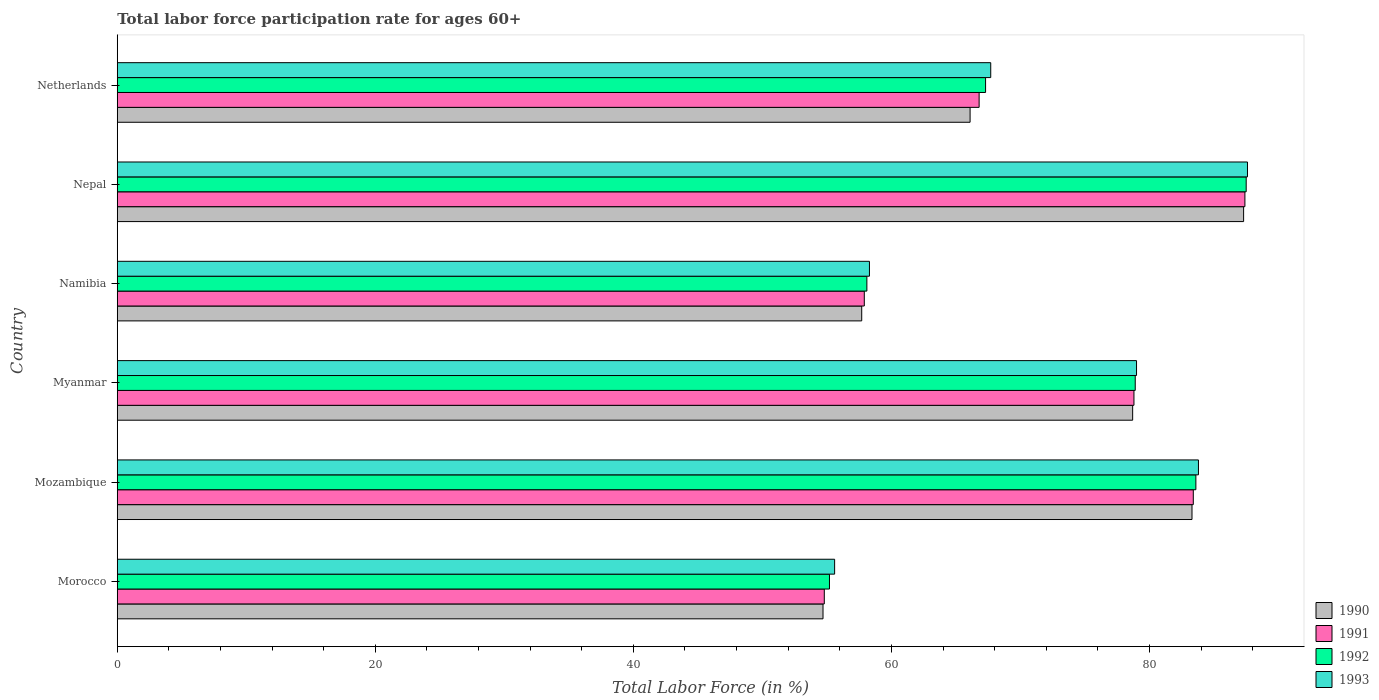How many different coloured bars are there?
Offer a terse response. 4. How many groups of bars are there?
Keep it short and to the point. 6. Are the number of bars per tick equal to the number of legend labels?
Offer a terse response. Yes. Are the number of bars on each tick of the Y-axis equal?
Provide a succinct answer. Yes. How many bars are there on the 6th tick from the top?
Ensure brevity in your answer.  4. How many bars are there on the 5th tick from the bottom?
Provide a succinct answer. 4. What is the label of the 5th group of bars from the top?
Your answer should be very brief. Mozambique. In how many cases, is the number of bars for a given country not equal to the number of legend labels?
Your response must be concise. 0. What is the labor force participation rate in 1991 in Netherlands?
Provide a succinct answer. 66.8. Across all countries, what is the maximum labor force participation rate in 1991?
Offer a terse response. 87.4. Across all countries, what is the minimum labor force participation rate in 1990?
Your answer should be very brief. 54.7. In which country was the labor force participation rate in 1990 maximum?
Offer a terse response. Nepal. In which country was the labor force participation rate in 1990 minimum?
Your response must be concise. Morocco. What is the total labor force participation rate in 1993 in the graph?
Offer a terse response. 432. What is the difference between the labor force participation rate in 1993 in Morocco and that in Netherlands?
Keep it short and to the point. -12.1. What is the difference between the labor force participation rate in 1992 in Mozambique and the labor force participation rate in 1990 in Morocco?
Offer a very short reply. 28.9. What is the average labor force participation rate in 1993 per country?
Offer a terse response. 72. What is the difference between the labor force participation rate in 1991 and labor force participation rate in 1992 in Myanmar?
Your answer should be compact. -0.1. In how many countries, is the labor force participation rate in 1991 greater than 44 %?
Give a very brief answer. 6. What is the ratio of the labor force participation rate in 1991 in Morocco to that in Namibia?
Provide a succinct answer. 0.95. Is the labor force participation rate in 1993 in Nepal less than that in Netherlands?
Ensure brevity in your answer.  No. Is the difference between the labor force participation rate in 1991 in Myanmar and Namibia greater than the difference between the labor force participation rate in 1992 in Myanmar and Namibia?
Ensure brevity in your answer.  Yes. What is the difference between the highest and the second highest labor force participation rate in 1992?
Keep it short and to the point. 3.9. What is the difference between the highest and the lowest labor force participation rate in 1992?
Keep it short and to the point. 32.3. In how many countries, is the labor force participation rate in 1990 greater than the average labor force participation rate in 1990 taken over all countries?
Your response must be concise. 3. What does the 3rd bar from the top in Mozambique represents?
Your answer should be compact. 1991. What is the difference between two consecutive major ticks on the X-axis?
Make the answer very short. 20. Does the graph contain grids?
Your answer should be very brief. No. How many legend labels are there?
Give a very brief answer. 4. What is the title of the graph?
Offer a terse response. Total labor force participation rate for ages 60+. What is the label or title of the Y-axis?
Give a very brief answer. Country. What is the Total Labor Force (in %) in 1990 in Morocco?
Offer a very short reply. 54.7. What is the Total Labor Force (in %) of 1991 in Morocco?
Offer a terse response. 54.8. What is the Total Labor Force (in %) in 1992 in Morocco?
Ensure brevity in your answer.  55.2. What is the Total Labor Force (in %) in 1993 in Morocco?
Make the answer very short. 55.6. What is the Total Labor Force (in %) in 1990 in Mozambique?
Keep it short and to the point. 83.3. What is the Total Labor Force (in %) in 1991 in Mozambique?
Your answer should be very brief. 83.4. What is the Total Labor Force (in %) in 1992 in Mozambique?
Your response must be concise. 83.6. What is the Total Labor Force (in %) of 1993 in Mozambique?
Your response must be concise. 83.8. What is the Total Labor Force (in %) in 1990 in Myanmar?
Your response must be concise. 78.7. What is the Total Labor Force (in %) of 1991 in Myanmar?
Your response must be concise. 78.8. What is the Total Labor Force (in %) in 1992 in Myanmar?
Provide a succinct answer. 78.9. What is the Total Labor Force (in %) of 1993 in Myanmar?
Your answer should be very brief. 79. What is the Total Labor Force (in %) of 1990 in Namibia?
Provide a succinct answer. 57.7. What is the Total Labor Force (in %) of 1991 in Namibia?
Provide a succinct answer. 57.9. What is the Total Labor Force (in %) of 1992 in Namibia?
Keep it short and to the point. 58.1. What is the Total Labor Force (in %) of 1993 in Namibia?
Provide a short and direct response. 58.3. What is the Total Labor Force (in %) in 1990 in Nepal?
Offer a terse response. 87.3. What is the Total Labor Force (in %) in 1991 in Nepal?
Keep it short and to the point. 87.4. What is the Total Labor Force (in %) in 1992 in Nepal?
Keep it short and to the point. 87.5. What is the Total Labor Force (in %) of 1993 in Nepal?
Give a very brief answer. 87.6. What is the Total Labor Force (in %) in 1990 in Netherlands?
Offer a terse response. 66.1. What is the Total Labor Force (in %) of 1991 in Netherlands?
Your answer should be very brief. 66.8. What is the Total Labor Force (in %) in 1992 in Netherlands?
Give a very brief answer. 67.3. What is the Total Labor Force (in %) in 1993 in Netherlands?
Provide a succinct answer. 67.7. Across all countries, what is the maximum Total Labor Force (in %) in 1990?
Keep it short and to the point. 87.3. Across all countries, what is the maximum Total Labor Force (in %) of 1991?
Give a very brief answer. 87.4. Across all countries, what is the maximum Total Labor Force (in %) in 1992?
Give a very brief answer. 87.5. Across all countries, what is the maximum Total Labor Force (in %) in 1993?
Keep it short and to the point. 87.6. Across all countries, what is the minimum Total Labor Force (in %) of 1990?
Provide a succinct answer. 54.7. Across all countries, what is the minimum Total Labor Force (in %) of 1991?
Make the answer very short. 54.8. Across all countries, what is the minimum Total Labor Force (in %) in 1992?
Ensure brevity in your answer.  55.2. Across all countries, what is the minimum Total Labor Force (in %) in 1993?
Offer a very short reply. 55.6. What is the total Total Labor Force (in %) of 1990 in the graph?
Give a very brief answer. 427.8. What is the total Total Labor Force (in %) in 1991 in the graph?
Provide a succinct answer. 429.1. What is the total Total Labor Force (in %) of 1992 in the graph?
Your answer should be compact. 430.6. What is the total Total Labor Force (in %) of 1993 in the graph?
Give a very brief answer. 432. What is the difference between the Total Labor Force (in %) of 1990 in Morocco and that in Mozambique?
Keep it short and to the point. -28.6. What is the difference between the Total Labor Force (in %) in 1991 in Morocco and that in Mozambique?
Keep it short and to the point. -28.6. What is the difference between the Total Labor Force (in %) of 1992 in Morocco and that in Mozambique?
Your answer should be compact. -28.4. What is the difference between the Total Labor Force (in %) of 1993 in Morocco and that in Mozambique?
Keep it short and to the point. -28.2. What is the difference between the Total Labor Force (in %) of 1990 in Morocco and that in Myanmar?
Keep it short and to the point. -24. What is the difference between the Total Labor Force (in %) of 1991 in Morocco and that in Myanmar?
Ensure brevity in your answer.  -24. What is the difference between the Total Labor Force (in %) in 1992 in Morocco and that in Myanmar?
Give a very brief answer. -23.7. What is the difference between the Total Labor Force (in %) in 1993 in Morocco and that in Myanmar?
Provide a succinct answer. -23.4. What is the difference between the Total Labor Force (in %) in 1991 in Morocco and that in Namibia?
Your response must be concise. -3.1. What is the difference between the Total Labor Force (in %) in 1992 in Morocco and that in Namibia?
Keep it short and to the point. -2.9. What is the difference between the Total Labor Force (in %) in 1993 in Morocco and that in Namibia?
Offer a terse response. -2.7. What is the difference between the Total Labor Force (in %) of 1990 in Morocco and that in Nepal?
Provide a succinct answer. -32.6. What is the difference between the Total Labor Force (in %) in 1991 in Morocco and that in Nepal?
Keep it short and to the point. -32.6. What is the difference between the Total Labor Force (in %) of 1992 in Morocco and that in Nepal?
Provide a succinct answer. -32.3. What is the difference between the Total Labor Force (in %) of 1993 in Morocco and that in Nepal?
Offer a very short reply. -32. What is the difference between the Total Labor Force (in %) in 1991 in Morocco and that in Netherlands?
Your answer should be compact. -12. What is the difference between the Total Labor Force (in %) of 1993 in Morocco and that in Netherlands?
Keep it short and to the point. -12.1. What is the difference between the Total Labor Force (in %) of 1990 in Mozambique and that in Myanmar?
Ensure brevity in your answer.  4.6. What is the difference between the Total Labor Force (in %) in 1991 in Mozambique and that in Myanmar?
Your response must be concise. 4.6. What is the difference between the Total Labor Force (in %) of 1993 in Mozambique and that in Myanmar?
Offer a terse response. 4.8. What is the difference between the Total Labor Force (in %) in 1990 in Mozambique and that in Namibia?
Give a very brief answer. 25.6. What is the difference between the Total Labor Force (in %) of 1991 in Mozambique and that in Namibia?
Keep it short and to the point. 25.5. What is the difference between the Total Labor Force (in %) in 1992 in Mozambique and that in Namibia?
Provide a short and direct response. 25.5. What is the difference between the Total Labor Force (in %) of 1993 in Mozambique and that in Namibia?
Make the answer very short. 25.5. What is the difference between the Total Labor Force (in %) of 1992 in Mozambique and that in Nepal?
Provide a short and direct response. -3.9. What is the difference between the Total Labor Force (in %) of 1993 in Mozambique and that in Nepal?
Your response must be concise. -3.8. What is the difference between the Total Labor Force (in %) in 1992 in Mozambique and that in Netherlands?
Provide a short and direct response. 16.3. What is the difference between the Total Labor Force (in %) of 1991 in Myanmar and that in Namibia?
Give a very brief answer. 20.9. What is the difference between the Total Labor Force (in %) of 1992 in Myanmar and that in Namibia?
Offer a terse response. 20.8. What is the difference between the Total Labor Force (in %) of 1993 in Myanmar and that in Namibia?
Give a very brief answer. 20.7. What is the difference between the Total Labor Force (in %) of 1991 in Myanmar and that in Nepal?
Provide a succinct answer. -8.6. What is the difference between the Total Labor Force (in %) in 1992 in Myanmar and that in Nepal?
Provide a short and direct response. -8.6. What is the difference between the Total Labor Force (in %) of 1992 in Myanmar and that in Netherlands?
Make the answer very short. 11.6. What is the difference between the Total Labor Force (in %) of 1993 in Myanmar and that in Netherlands?
Give a very brief answer. 11.3. What is the difference between the Total Labor Force (in %) in 1990 in Namibia and that in Nepal?
Provide a succinct answer. -29.6. What is the difference between the Total Labor Force (in %) of 1991 in Namibia and that in Nepal?
Your answer should be very brief. -29.5. What is the difference between the Total Labor Force (in %) of 1992 in Namibia and that in Nepal?
Make the answer very short. -29.4. What is the difference between the Total Labor Force (in %) in 1993 in Namibia and that in Nepal?
Offer a terse response. -29.3. What is the difference between the Total Labor Force (in %) in 1991 in Namibia and that in Netherlands?
Give a very brief answer. -8.9. What is the difference between the Total Labor Force (in %) of 1992 in Namibia and that in Netherlands?
Offer a terse response. -9.2. What is the difference between the Total Labor Force (in %) in 1990 in Nepal and that in Netherlands?
Keep it short and to the point. 21.2. What is the difference between the Total Labor Force (in %) of 1991 in Nepal and that in Netherlands?
Provide a short and direct response. 20.6. What is the difference between the Total Labor Force (in %) in 1992 in Nepal and that in Netherlands?
Your answer should be very brief. 20.2. What is the difference between the Total Labor Force (in %) of 1993 in Nepal and that in Netherlands?
Ensure brevity in your answer.  19.9. What is the difference between the Total Labor Force (in %) of 1990 in Morocco and the Total Labor Force (in %) of 1991 in Mozambique?
Make the answer very short. -28.7. What is the difference between the Total Labor Force (in %) of 1990 in Morocco and the Total Labor Force (in %) of 1992 in Mozambique?
Offer a very short reply. -28.9. What is the difference between the Total Labor Force (in %) in 1990 in Morocco and the Total Labor Force (in %) in 1993 in Mozambique?
Offer a terse response. -29.1. What is the difference between the Total Labor Force (in %) in 1991 in Morocco and the Total Labor Force (in %) in 1992 in Mozambique?
Make the answer very short. -28.8. What is the difference between the Total Labor Force (in %) in 1992 in Morocco and the Total Labor Force (in %) in 1993 in Mozambique?
Your answer should be very brief. -28.6. What is the difference between the Total Labor Force (in %) of 1990 in Morocco and the Total Labor Force (in %) of 1991 in Myanmar?
Make the answer very short. -24.1. What is the difference between the Total Labor Force (in %) of 1990 in Morocco and the Total Labor Force (in %) of 1992 in Myanmar?
Keep it short and to the point. -24.2. What is the difference between the Total Labor Force (in %) in 1990 in Morocco and the Total Labor Force (in %) in 1993 in Myanmar?
Your answer should be compact. -24.3. What is the difference between the Total Labor Force (in %) of 1991 in Morocco and the Total Labor Force (in %) of 1992 in Myanmar?
Keep it short and to the point. -24.1. What is the difference between the Total Labor Force (in %) in 1991 in Morocco and the Total Labor Force (in %) in 1993 in Myanmar?
Make the answer very short. -24.2. What is the difference between the Total Labor Force (in %) of 1992 in Morocco and the Total Labor Force (in %) of 1993 in Myanmar?
Offer a very short reply. -23.8. What is the difference between the Total Labor Force (in %) in 1990 in Morocco and the Total Labor Force (in %) in 1991 in Namibia?
Keep it short and to the point. -3.2. What is the difference between the Total Labor Force (in %) of 1990 in Morocco and the Total Labor Force (in %) of 1993 in Namibia?
Ensure brevity in your answer.  -3.6. What is the difference between the Total Labor Force (in %) of 1991 in Morocco and the Total Labor Force (in %) of 1993 in Namibia?
Provide a succinct answer. -3.5. What is the difference between the Total Labor Force (in %) in 1990 in Morocco and the Total Labor Force (in %) in 1991 in Nepal?
Offer a terse response. -32.7. What is the difference between the Total Labor Force (in %) of 1990 in Morocco and the Total Labor Force (in %) of 1992 in Nepal?
Your answer should be very brief. -32.8. What is the difference between the Total Labor Force (in %) of 1990 in Morocco and the Total Labor Force (in %) of 1993 in Nepal?
Your answer should be very brief. -32.9. What is the difference between the Total Labor Force (in %) of 1991 in Morocco and the Total Labor Force (in %) of 1992 in Nepal?
Keep it short and to the point. -32.7. What is the difference between the Total Labor Force (in %) of 1991 in Morocco and the Total Labor Force (in %) of 1993 in Nepal?
Your answer should be very brief. -32.8. What is the difference between the Total Labor Force (in %) in 1992 in Morocco and the Total Labor Force (in %) in 1993 in Nepal?
Give a very brief answer. -32.4. What is the difference between the Total Labor Force (in %) of 1990 in Morocco and the Total Labor Force (in %) of 1992 in Netherlands?
Your response must be concise. -12.6. What is the difference between the Total Labor Force (in %) of 1991 in Morocco and the Total Labor Force (in %) of 1992 in Netherlands?
Provide a succinct answer. -12.5. What is the difference between the Total Labor Force (in %) of 1991 in Morocco and the Total Labor Force (in %) of 1993 in Netherlands?
Provide a succinct answer. -12.9. What is the difference between the Total Labor Force (in %) in 1991 in Mozambique and the Total Labor Force (in %) in 1992 in Myanmar?
Keep it short and to the point. 4.5. What is the difference between the Total Labor Force (in %) of 1991 in Mozambique and the Total Labor Force (in %) of 1993 in Myanmar?
Your answer should be compact. 4.4. What is the difference between the Total Labor Force (in %) in 1992 in Mozambique and the Total Labor Force (in %) in 1993 in Myanmar?
Make the answer very short. 4.6. What is the difference between the Total Labor Force (in %) of 1990 in Mozambique and the Total Labor Force (in %) of 1991 in Namibia?
Offer a terse response. 25.4. What is the difference between the Total Labor Force (in %) in 1990 in Mozambique and the Total Labor Force (in %) in 1992 in Namibia?
Offer a very short reply. 25.2. What is the difference between the Total Labor Force (in %) in 1991 in Mozambique and the Total Labor Force (in %) in 1992 in Namibia?
Give a very brief answer. 25.3. What is the difference between the Total Labor Force (in %) in 1991 in Mozambique and the Total Labor Force (in %) in 1993 in Namibia?
Your answer should be very brief. 25.1. What is the difference between the Total Labor Force (in %) in 1992 in Mozambique and the Total Labor Force (in %) in 1993 in Namibia?
Offer a very short reply. 25.3. What is the difference between the Total Labor Force (in %) of 1990 in Mozambique and the Total Labor Force (in %) of 1991 in Nepal?
Your answer should be compact. -4.1. What is the difference between the Total Labor Force (in %) of 1990 in Mozambique and the Total Labor Force (in %) of 1993 in Nepal?
Make the answer very short. -4.3. What is the difference between the Total Labor Force (in %) of 1991 in Mozambique and the Total Labor Force (in %) of 1992 in Nepal?
Keep it short and to the point. -4.1. What is the difference between the Total Labor Force (in %) in 1991 in Mozambique and the Total Labor Force (in %) in 1993 in Nepal?
Your response must be concise. -4.2. What is the difference between the Total Labor Force (in %) in 1992 in Mozambique and the Total Labor Force (in %) in 1993 in Nepal?
Your answer should be very brief. -4. What is the difference between the Total Labor Force (in %) of 1990 in Mozambique and the Total Labor Force (in %) of 1991 in Netherlands?
Your answer should be compact. 16.5. What is the difference between the Total Labor Force (in %) in 1990 in Mozambique and the Total Labor Force (in %) in 1993 in Netherlands?
Offer a very short reply. 15.6. What is the difference between the Total Labor Force (in %) in 1992 in Mozambique and the Total Labor Force (in %) in 1993 in Netherlands?
Provide a short and direct response. 15.9. What is the difference between the Total Labor Force (in %) of 1990 in Myanmar and the Total Labor Force (in %) of 1991 in Namibia?
Provide a short and direct response. 20.8. What is the difference between the Total Labor Force (in %) of 1990 in Myanmar and the Total Labor Force (in %) of 1992 in Namibia?
Your answer should be very brief. 20.6. What is the difference between the Total Labor Force (in %) in 1990 in Myanmar and the Total Labor Force (in %) in 1993 in Namibia?
Provide a succinct answer. 20.4. What is the difference between the Total Labor Force (in %) in 1991 in Myanmar and the Total Labor Force (in %) in 1992 in Namibia?
Ensure brevity in your answer.  20.7. What is the difference between the Total Labor Force (in %) of 1991 in Myanmar and the Total Labor Force (in %) of 1993 in Namibia?
Offer a very short reply. 20.5. What is the difference between the Total Labor Force (in %) in 1992 in Myanmar and the Total Labor Force (in %) in 1993 in Namibia?
Give a very brief answer. 20.6. What is the difference between the Total Labor Force (in %) of 1990 in Myanmar and the Total Labor Force (in %) of 1991 in Nepal?
Provide a short and direct response. -8.7. What is the difference between the Total Labor Force (in %) of 1990 in Myanmar and the Total Labor Force (in %) of 1993 in Nepal?
Your response must be concise. -8.9. What is the difference between the Total Labor Force (in %) in 1992 in Myanmar and the Total Labor Force (in %) in 1993 in Nepal?
Your answer should be compact. -8.7. What is the difference between the Total Labor Force (in %) in 1990 in Myanmar and the Total Labor Force (in %) in 1991 in Netherlands?
Your response must be concise. 11.9. What is the difference between the Total Labor Force (in %) in 1990 in Myanmar and the Total Labor Force (in %) in 1992 in Netherlands?
Your answer should be compact. 11.4. What is the difference between the Total Labor Force (in %) in 1991 in Myanmar and the Total Labor Force (in %) in 1992 in Netherlands?
Provide a succinct answer. 11.5. What is the difference between the Total Labor Force (in %) in 1991 in Myanmar and the Total Labor Force (in %) in 1993 in Netherlands?
Your answer should be compact. 11.1. What is the difference between the Total Labor Force (in %) of 1990 in Namibia and the Total Labor Force (in %) of 1991 in Nepal?
Your response must be concise. -29.7. What is the difference between the Total Labor Force (in %) in 1990 in Namibia and the Total Labor Force (in %) in 1992 in Nepal?
Your answer should be very brief. -29.8. What is the difference between the Total Labor Force (in %) in 1990 in Namibia and the Total Labor Force (in %) in 1993 in Nepal?
Give a very brief answer. -29.9. What is the difference between the Total Labor Force (in %) in 1991 in Namibia and the Total Labor Force (in %) in 1992 in Nepal?
Give a very brief answer. -29.6. What is the difference between the Total Labor Force (in %) in 1991 in Namibia and the Total Labor Force (in %) in 1993 in Nepal?
Your answer should be compact. -29.7. What is the difference between the Total Labor Force (in %) of 1992 in Namibia and the Total Labor Force (in %) of 1993 in Nepal?
Ensure brevity in your answer.  -29.5. What is the difference between the Total Labor Force (in %) of 1990 in Namibia and the Total Labor Force (in %) of 1991 in Netherlands?
Your response must be concise. -9.1. What is the difference between the Total Labor Force (in %) of 1990 in Namibia and the Total Labor Force (in %) of 1992 in Netherlands?
Your answer should be compact. -9.6. What is the difference between the Total Labor Force (in %) of 1990 in Namibia and the Total Labor Force (in %) of 1993 in Netherlands?
Offer a very short reply. -10. What is the difference between the Total Labor Force (in %) of 1990 in Nepal and the Total Labor Force (in %) of 1991 in Netherlands?
Offer a very short reply. 20.5. What is the difference between the Total Labor Force (in %) of 1990 in Nepal and the Total Labor Force (in %) of 1993 in Netherlands?
Provide a short and direct response. 19.6. What is the difference between the Total Labor Force (in %) in 1991 in Nepal and the Total Labor Force (in %) in 1992 in Netherlands?
Offer a very short reply. 20.1. What is the difference between the Total Labor Force (in %) in 1991 in Nepal and the Total Labor Force (in %) in 1993 in Netherlands?
Provide a short and direct response. 19.7. What is the difference between the Total Labor Force (in %) in 1992 in Nepal and the Total Labor Force (in %) in 1993 in Netherlands?
Offer a very short reply. 19.8. What is the average Total Labor Force (in %) of 1990 per country?
Your response must be concise. 71.3. What is the average Total Labor Force (in %) of 1991 per country?
Offer a very short reply. 71.52. What is the average Total Labor Force (in %) of 1992 per country?
Offer a very short reply. 71.77. What is the average Total Labor Force (in %) in 1993 per country?
Make the answer very short. 72. What is the difference between the Total Labor Force (in %) of 1991 and Total Labor Force (in %) of 1992 in Morocco?
Offer a very short reply. -0.4. What is the difference between the Total Labor Force (in %) of 1991 and Total Labor Force (in %) of 1993 in Morocco?
Make the answer very short. -0.8. What is the difference between the Total Labor Force (in %) of 1990 and Total Labor Force (in %) of 1991 in Mozambique?
Ensure brevity in your answer.  -0.1. What is the difference between the Total Labor Force (in %) in 1990 and Total Labor Force (in %) in 1993 in Mozambique?
Your answer should be compact. -0.5. What is the difference between the Total Labor Force (in %) in 1991 and Total Labor Force (in %) in 1992 in Mozambique?
Offer a very short reply. -0.2. What is the difference between the Total Labor Force (in %) of 1991 and Total Labor Force (in %) of 1993 in Mozambique?
Provide a succinct answer. -0.4. What is the difference between the Total Labor Force (in %) of 1992 and Total Labor Force (in %) of 1993 in Mozambique?
Keep it short and to the point. -0.2. What is the difference between the Total Labor Force (in %) in 1990 and Total Labor Force (in %) in 1992 in Myanmar?
Your response must be concise. -0.2. What is the difference between the Total Labor Force (in %) of 1991 and Total Labor Force (in %) of 1992 in Myanmar?
Provide a short and direct response. -0.1. What is the difference between the Total Labor Force (in %) in 1991 and Total Labor Force (in %) in 1993 in Myanmar?
Provide a short and direct response. -0.2. What is the difference between the Total Labor Force (in %) in 1990 and Total Labor Force (in %) in 1992 in Namibia?
Your answer should be compact. -0.4. What is the difference between the Total Labor Force (in %) of 1990 and Total Labor Force (in %) of 1991 in Nepal?
Give a very brief answer. -0.1. What is the difference between the Total Labor Force (in %) in 1990 and Total Labor Force (in %) in 1992 in Netherlands?
Ensure brevity in your answer.  -1.2. What is the difference between the Total Labor Force (in %) in 1990 and Total Labor Force (in %) in 1993 in Netherlands?
Make the answer very short. -1.6. What is the ratio of the Total Labor Force (in %) of 1990 in Morocco to that in Mozambique?
Provide a succinct answer. 0.66. What is the ratio of the Total Labor Force (in %) in 1991 in Morocco to that in Mozambique?
Your answer should be very brief. 0.66. What is the ratio of the Total Labor Force (in %) of 1992 in Morocco to that in Mozambique?
Offer a terse response. 0.66. What is the ratio of the Total Labor Force (in %) in 1993 in Morocco to that in Mozambique?
Keep it short and to the point. 0.66. What is the ratio of the Total Labor Force (in %) in 1990 in Morocco to that in Myanmar?
Your response must be concise. 0.69. What is the ratio of the Total Labor Force (in %) in 1991 in Morocco to that in Myanmar?
Your answer should be very brief. 0.7. What is the ratio of the Total Labor Force (in %) in 1992 in Morocco to that in Myanmar?
Your response must be concise. 0.7. What is the ratio of the Total Labor Force (in %) in 1993 in Morocco to that in Myanmar?
Provide a succinct answer. 0.7. What is the ratio of the Total Labor Force (in %) of 1990 in Morocco to that in Namibia?
Your response must be concise. 0.95. What is the ratio of the Total Labor Force (in %) of 1991 in Morocco to that in Namibia?
Provide a short and direct response. 0.95. What is the ratio of the Total Labor Force (in %) of 1992 in Morocco to that in Namibia?
Keep it short and to the point. 0.95. What is the ratio of the Total Labor Force (in %) in 1993 in Morocco to that in Namibia?
Provide a short and direct response. 0.95. What is the ratio of the Total Labor Force (in %) of 1990 in Morocco to that in Nepal?
Provide a short and direct response. 0.63. What is the ratio of the Total Labor Force (in %) in 1991 in Morocco to that in Nepal?
Offer a very short reply. 0.63. What is the ratio of the Total Labor Force (in %) in 1992 in Morocco to that in Nepal?
Offer a terse response. 0.63. What is the ratio of the Total Labor Force (in %) of 1993 in Morocco to that in Nepal?
Give a very brief answer. 0.63. What is the ratio of the Total Labor Force (in %) of 1990 in Morocco to that in Netherlands?
Your response must be concise. 0.83. What is the ratio of the Total Labor Force (in %) in 1991 in Morocco to that in Netherlands?
Give a very brief answer. 0.82. What is the ratio of the Total Labor Force (in %) in 1992 in Morocco to that in Netherlands?
Your response must be concise. 0.82. What is the ratio of the Total Labor Force (in %) of 1993 in Morocco to that in Netherlands?
Your answer should be compact. 0.82. What is the ratio of the Total Labor Force (in %) of 1990 in Mozambique to that in Myanmar?
Provide a short and direct response. 1.06. What is the ratio of the Total Labor Force (in %) in 1991 in Mozambique to that in Myanmar?
Make the answer very short. 1.06. What is the ratio of the Total Labor Force (in %) of 1992 in Mozambique to that in Myanmar?
Give a very brief answer. 1.06. What is the ratio of the Total Labor Force (in %) of 1993 in Mozambique to that in Myanmar?
Your answer should be very brief. 1.06. What is the ratio of the Total Labor Force (in %) of 1990 in Mozambique to that in Namibia?
Provide a succinct answer. 1.44. What is the ratio of the Total Labor Force (in %) in 1991 in Mozambique to that in Namibia?
Provide a short and direct response. 1.44. What is the ratio of the Total Labor Force (in %) in 1992 in Mozambique to that in Namibia?
Offer a terse response. 1.44. What is the ratio of the Total Labor Force (in %) of 1993 in Mozambique to that in Namibia?
Give a very brief answer. 1.44. What is the ratio of the Total Labor Force (in %) of 1990 in Mozambique to that in Nepal?
Provide a short and direct response. 0.95. What is the ratio of the Total Labor Force (in %) of 1991 in Mozambique to that in Nepal?
Make the answer very short. 0.95. What is the ratio of the Total Labor Force (in %) in 1992 in Mozambique to that in Nepal?
Keep it short and to the point. 0.96. What is the ratio of the Total Labor Force (in %) in 1993 in Mozambique to that in Nepal?
Your answer should be compact. 0.96. What is the ratio of the Total Labor Force (in %) of 1990 in Mozambique to that in Netherlands?
Give a very brief answer. 1.26. What is the ratio of the Total Labor Force (in %) of 1991 in Mozambique to that in Netherlands?
Give a very brief answer. 1.25. What is the ratio of the Total Labor Force (in %) in 1992 in Mozambique to that in Netherlands?
Your response must be concise. 1.24. What is the ratio of the Total Labor Force (in %) of 1993 in Mozambique to that in Netherlands?
Make the answer very short. 1.24. What is the ratio of the Total Labor Force (in %) of 1990 in Myanmar to that in Namibia?
Give a very brief answer. 1.36. What is the ratio of the Total Labor Force (in %) in 1991 in Myanmar to that in Namibia?
Your response must be concise. 1.36. What is the ratio of the Total Labor Force (in %) in 1992 in Myanmar to that in Namibia?
Provide a short and direct response. 1.36. What is the ratio of the Total Labor Force (in %) of 1993 in Myanmar to that in Namibia?
Offer a very short reply. 1.36. What is the ratio of the Total Labor Force (in %) in 1990 in Myanmar to that in Nepal?
Ensure brevity in your answer.  0.9. What is the ratio of the Total Labor Force (in %) in 1991 in Myanmar to that in Nepal?
Provide a short and direct response. 0.9. What is the ratio of the Total Labor Force (in %) of 1992 in Myanmar to that in Nepal?
Your answer should be compact. 0.9. What is the ratio of the Total Labor Force (in %) of 1993 in Myanmar to that in Nepal?
Offer a very short reply. 0.9. What is the ratio of the Total Labor Force (in %) in 1990 in Myanmar to that in Netherlands?
Give a very brief answer. 1.19. What is the ratio of the Total Labor Force (in %) in 1991 in Myanmar to that in Netherlands?
Give a very brief answer. 1.18. What is the ratio of the Total Labor Force (in %) of 1992 in Myanmar to that in Netherlands?
Your answer should be very brief. 1.17. What is the ratio of the Total Labor Force (in %) in 1993 in Myanmar to that in Netherlands?
Provide a succinct answer. 1.17. What is the ratio of the Total Labor Force (in %) in 1990 in Namibia to that in Nepal?
Give a very brief answer. 0.66. What is the ratio of the Total Labor Force (in %) in 1991 in Namibia to that in Nepal?
Offer a very short reply. 0.66. What is the ratio of the Total Labor Force (in %) of 1992 in Namibia to that in Nepal?
Provide a short and direct response. 0.66. What is the ratio of the Total Labor Force (in %) in 1993 in Namibia to that in Nepal?
Provide a short and direct response. 0.67. What is the ratio of the Total Labor Force (in %) in 1990 in Namibia to that in Netherlands?
Provide a succinct answer. 0.87. What is the ratio of the Total Labor Force (in %) in 1991 in Namibia to that in Netherlands?
Provide a succinct answer. 0.87. What is the ratio of the Total Labor Force (in %) in 1992 in Namibia to that in Netherlands?
Your answer should be compact. 0.86. What is the ratio of the Total Labor Force (in %) of 1993 in Namibia to that in Netherlands?
Your response must be concise. 0.86. What is the ratio of the Total Labor Force (in %) in 1990 in Nepal to that in Netherlands?
Provide a succinct answer. 1.32. What is the ratio of the Total Labor Force (in %) of 1991 in Nepal to that in Netherlands?
Offer a terse response. 1.31. What is the ratio of the Total Labor Force (in %) of 1992 in Nepal to that in Netherlands?
Your response must be concise. 1.3. What is the ratio of the Total Labor Force (in %) in 1993 in Nepal to that in Netherlands?
Make the answer very short. 1.29. What is the difference between the highest and the second highest Total Labor Force (in %) of 1990?
Give a very brief answer. 4. What is the difference between the highest and the second highest Total Labor Force (in %) in 1991?
Offer a terse response. 4. What is the difference between the highest and the second highest Total Labor Force (in %) of 1992?
Your answer should be compact. 3.9. What is the difference between the highest and the lowest Total Labor Force (in %) of 1990?
Offer a terse response. 32.6. What is the difference between the highest and the lowest Total Labor Force (in %) of 1991?
Offer a very short reply. 32.6. What is the difference between the highest and the lowest Total Labor Force (in %) in 1992?
Ensure brevity in your answer.  32.3. What is the difference between the highest and the lowest Total Labor Force (in %) of 1993?
Your answer should be very brief. 32. 